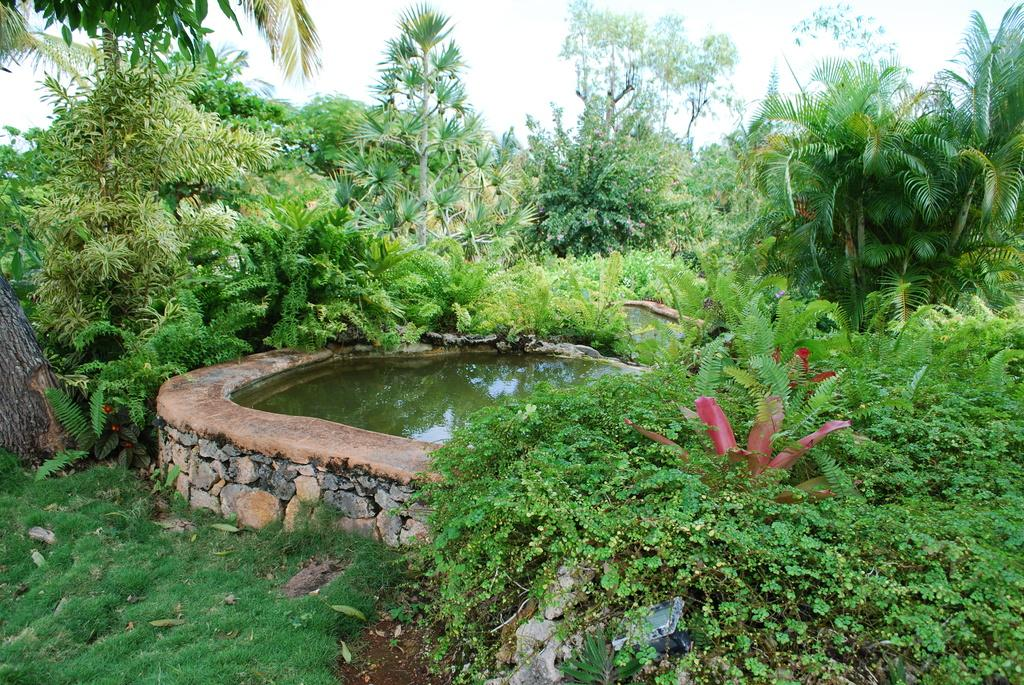What is the main feature in the center of the image? There is a pond in the center of the image. What can be seen in the background of the image? There are trees, plants, and grass in the background of the image. What is visible at the top of the image? The sky is visible at the top of the image. What type of mouth can be seen on the beast in the image? There is no beast present in the image, so there is no mouth to observe. 